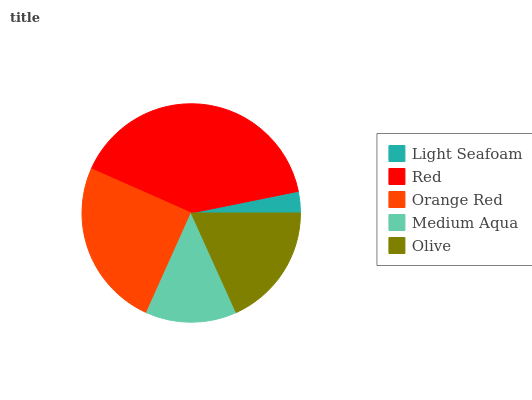Is Light Seafoam the minimum?
Answer yes or no. Yes. Is Red the maximum?
Answer yes or no. Yes. Is Orange Red the minimum?
Answer yes or no. No. Is Orange Red the maximum?
Answer yes or no. No. Is Red greater than Orange Red?
Answer yes or no. Yes. Is Orange Red less than Red?
Answer yes or no. Yes. Is Orange Red greater than Red?
Answer yes or no. No. Is Red less than Orange Red?
Answer yes or no. No. Is Olive the high median?
Answer yes or no. Yes. Is Olive the low median?
Answer yes or no. Yes. Is Orange Red the high median?
Answer yes or no. No. Is Medium Aqua the low median?
Answer yes or no. No. 